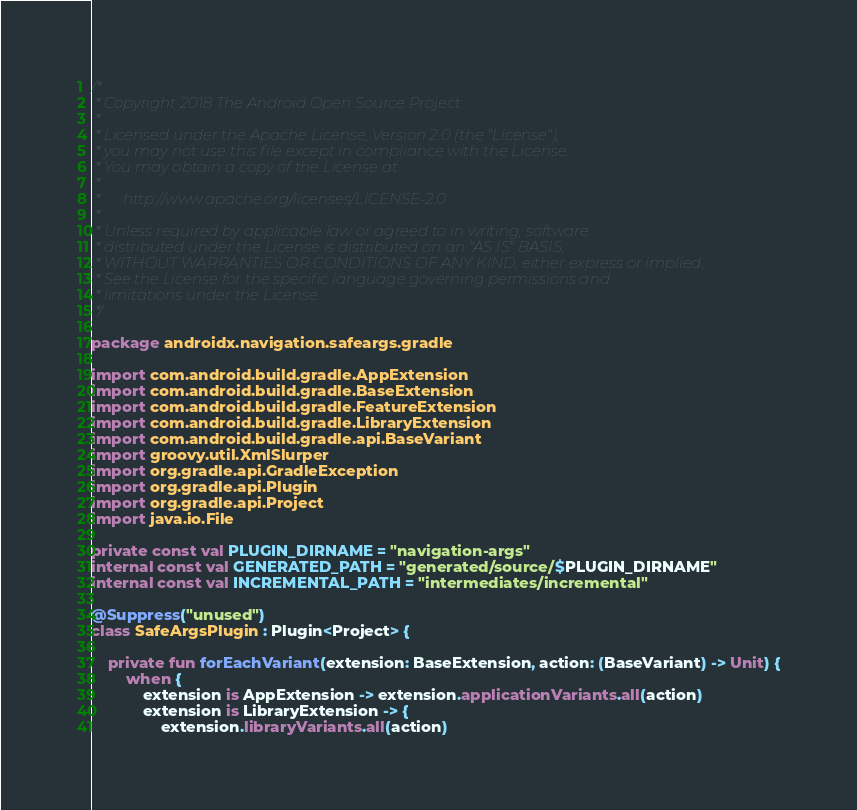<code> <loc_0><loc_0><loc_500><loc_500><_Kotlin_>/*
 * Copyright 2018 The Android Open Source Project
 *
 * Licensed under the Apache License, Version 2.0 (the "License");
 * you may not use this file except in compliance with the License.
 * You may obtain a copy of the License at
 *
 *      http://www.apache.org/licenses/LICENSE-2.0
 *
 * Unless required by applicable law or agreed to in writing, software
 * distributed under the License is distributed on an "AS IS" BASIS,
 * WITHOUT WARRANTIES OR CONDITIONS OF ANY KIND, either express or implied.
 * See the License for the specific language governing permissions and
 * limitations under the License.
 */

package androidx.navigation.safeargs.gradle

import com.android.build.gradle.AppExtension
import com.android.build.gradle.BaseExtension
import com.android.build.gradle.FeatureExtension
import com.android.build.gradle.LibraryExtension
import com.android.build.gradle.api.BaseVariant
import groovy.util.XmlSlurper
import org.gradle.api.GradleException
import org.gradle.api.Plugin
import org.gradle.api.Project
import java.io.File

private const val PLUGIN_DIRNAME = "navigation-args"
internal const val GENERATED_PATH = "generated/source/$PLUGIN_DIRNAME"
internal const val INCREMENTAL_PATH = "intermediates/incremental"

@Suppress("unused")
class SafeArgsPlugin : Plugin<Project> {

    private fun forEachVariant(extension: BaseExtension, action: (BaseVariant) -> Unit) {
        when {
            extension is AppExtension -> extension.applicationVariants.all(action)
            extension is LibraryExtension -> {
                extension.libraryVariants.all(action)</code> 